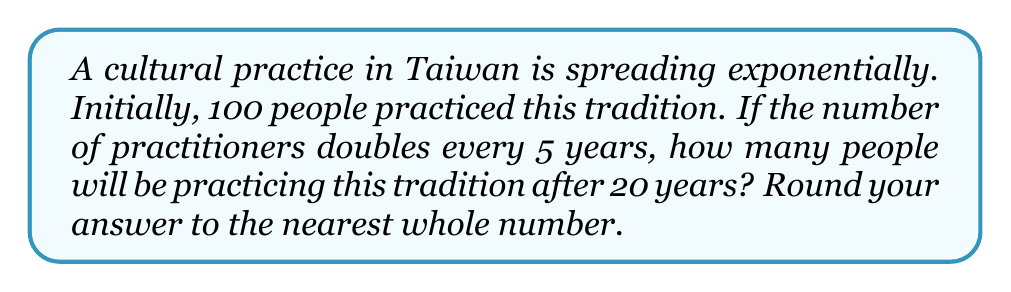Help me with this question. Let's approach this step-by-step:

1) We start with the basic exponential growth equation:
   $$ A = P(1 + r)^t $$
   Where:
   $A$ is the final amount
   $P$ is the initial amount (100 in this case)
   $r$ is the growth rate
   $t$ is the time period

2) In this case, the population doubles every 5 years. This means that in 5 years, the growth factor is 2. We can express this as:
   $$ 2 = (1 + r)^5 $$

3) Solving for $r$:
   $$ r = 2^{\frac{1}{5}} - 1 \approx 0.1487 \text{ or about } 14.87\% $$

4) Now, we know that:
   $P = 100$
   $r \approx 0.1487$
   $t = 20$ years

5) Plugging these into our original equation:
   $$ A = 100(1 + 0.1487)^{20} $$

6) Simplifying:
   $$ A \approx 100(1.1487)^{20} \approx 1600.3 $$

7) Rounding to the nearest whole number:
   $$ A \approx 1600 $$
Answer: 1600 